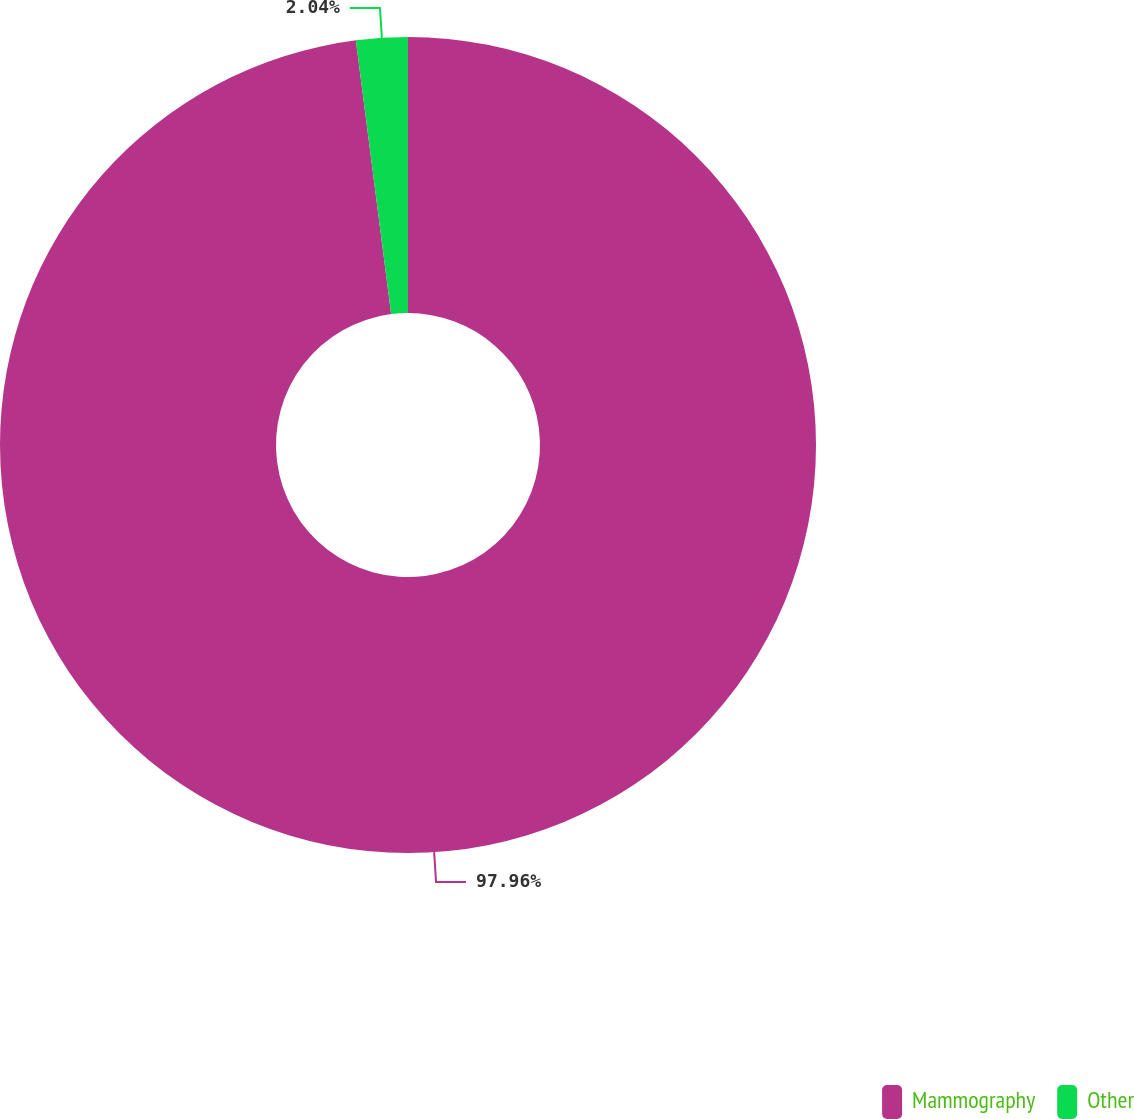Convert chart. <chart><loc_0><loc_0><loc_500><loc_500><pie_chart><fcel>Mammography<fcel>Other<nl><fcel>97.96%<fcel>2.04%<nl></chart> 